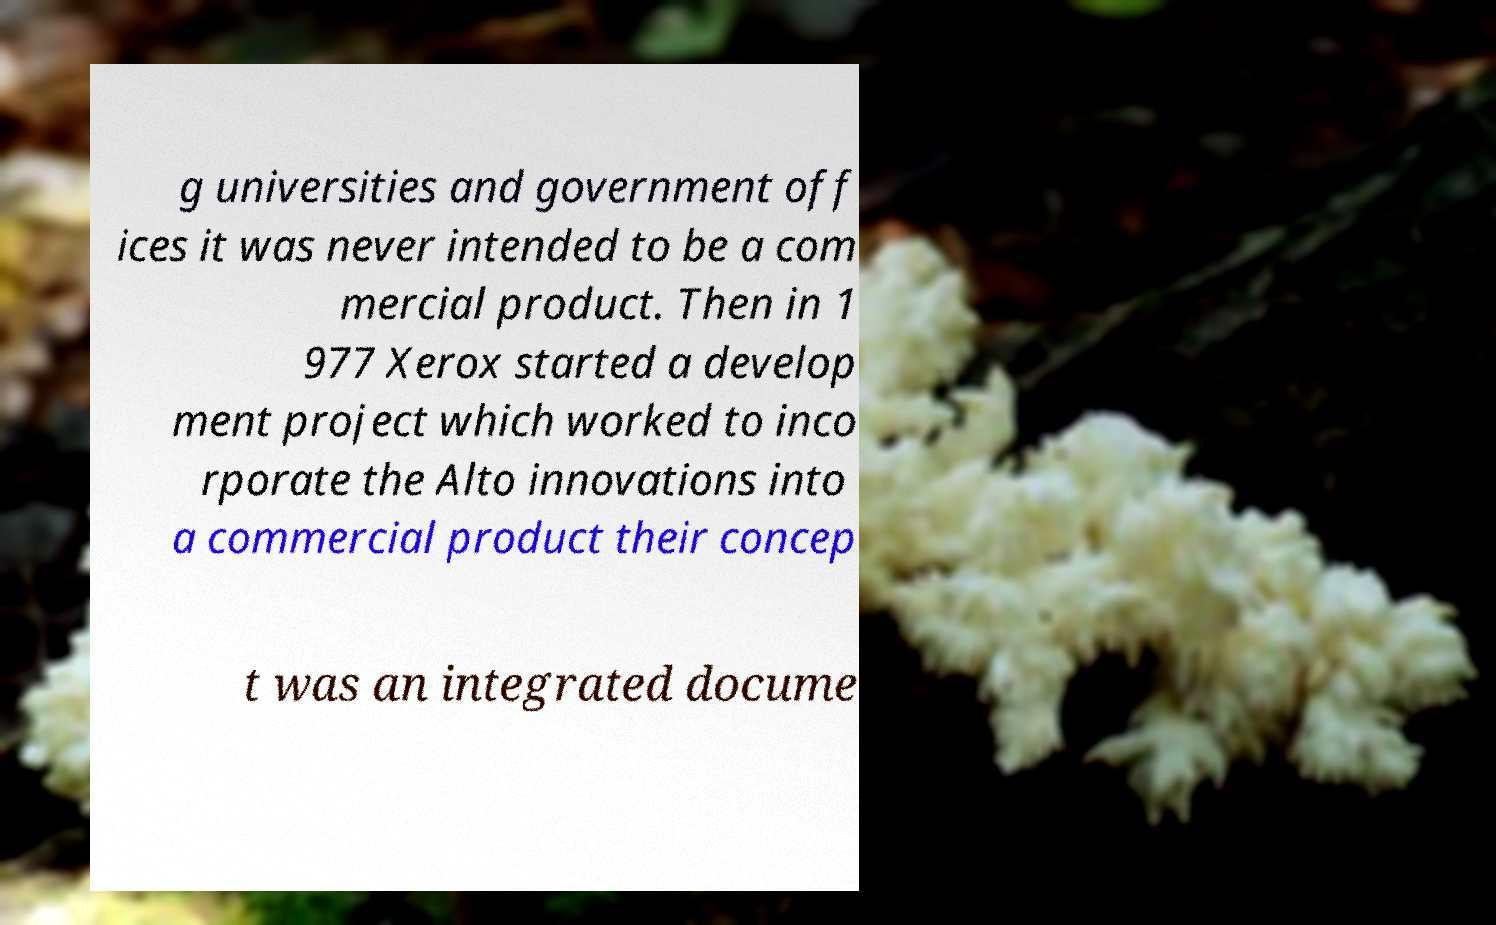Could you assist in decoding the text presented in this image and type it out clearly? g universities and government off ices it was never intended to be a com mercial product. Then in 1 977 Xerox started a develop ment project which worked to inco rporate the Alto innovations into a commercial product their concep t was an integrated docume 